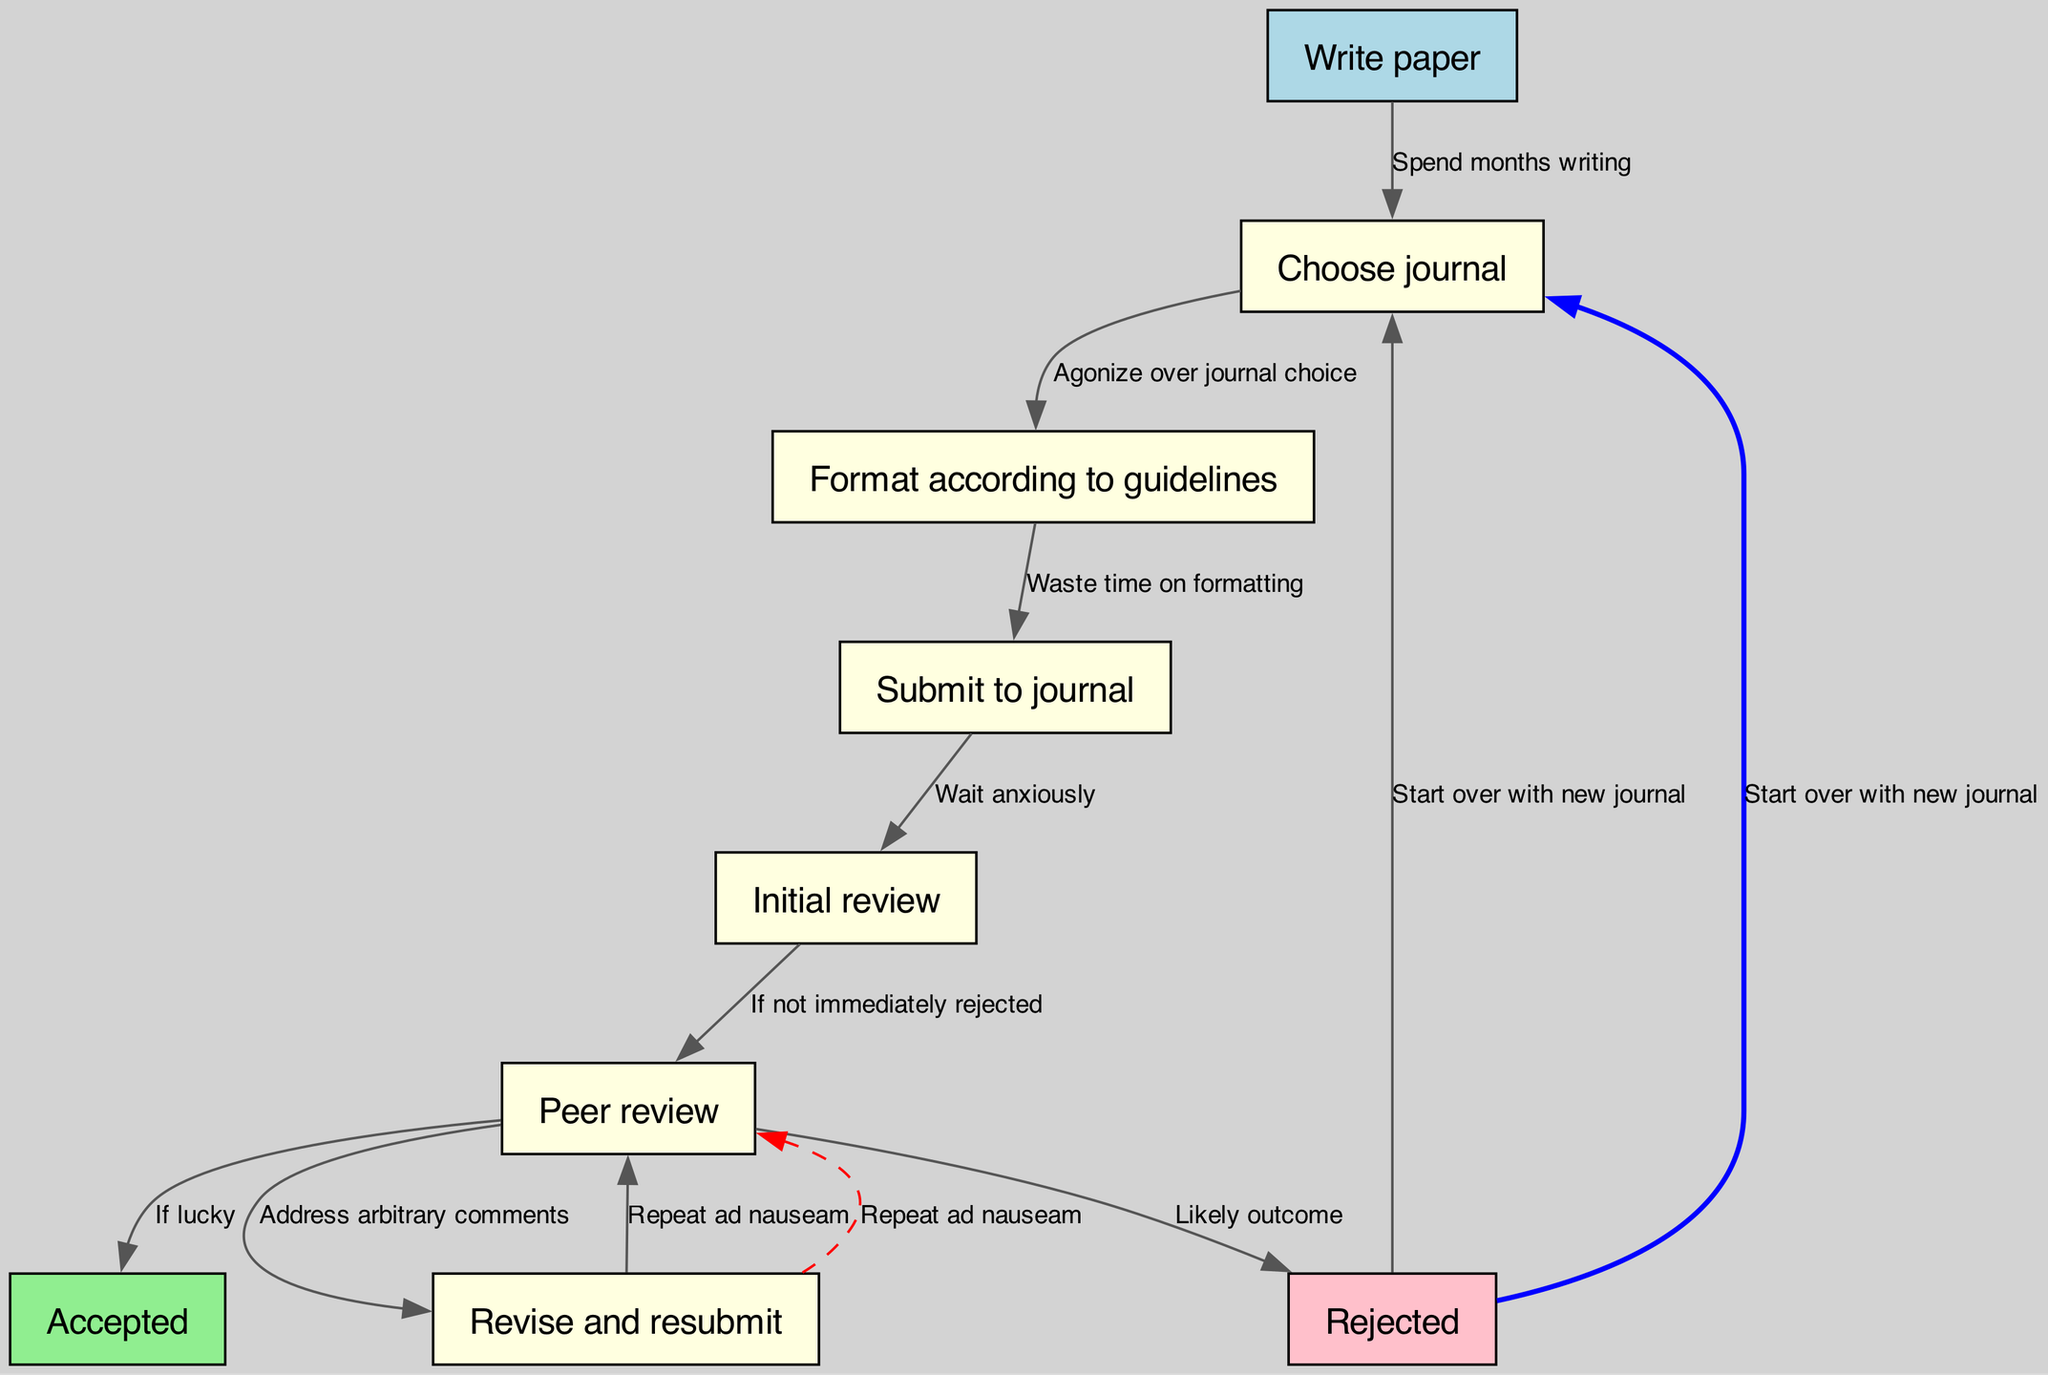What is the first step in the process? The first step is represented by node 1, which states "Write paper." This is the starting point of the flowchart and initiates the entire process of submitting an academic paper.
Answer: Write paper How many nodes are in the diagram? The diagram contains 9 distinct nodes that represent different steps in the paper submission process. By counting the nodes listed, we find a total of 9.
Answer: 9 What happens after the initial review? After the initial review, which is node 5, the process moves to node 6, "Peer review," provided the paper is not immediately rejected. This shows the flow of decisions made based on the review outcome.
Answer: Peer review What is the likely outcome after the peer review? According to the diagram, the likely outcome after the peer review (node 6) is "Rejected" (node 9), which indicates a common result for many submissions. This is also highlighted as a significant risk in the process.
Answer: Rejected What does the dashed edge represent? The dashed edge going from node 7 back to node 6 represents the iterative nature of the process, where authors must repeat the peer review stage multiple times to address revisions and comments. This signifies a continuous loop until acceptance or further rejection.
Answer: Repeat ad nauseam What do authors do if their paper is rejected? If rejected at node 9, the authors are directed back to node 2, "Choose journal," indicating that they must start over with a new journal option for resubmission. This creates a cycle back to an earlier step in the process.
Answer: Start over with new journal Which node indicates the paper's acceptance? The acceptance of the paper is indicated by node 8, "Accepted." This node signifies a successful outcome in the flow of the academic paper submission process.
Answer: Accepted What is the consequence of choosing the wrong journal? Choosing the wrong journal is implied in the process, especially during the "Agonize over journal choice" phase, leading potentially to a rejection and the need to start over. Thus, it highlights the importance of strategic selection in the submission journey.
Answer: Start over with new journal 